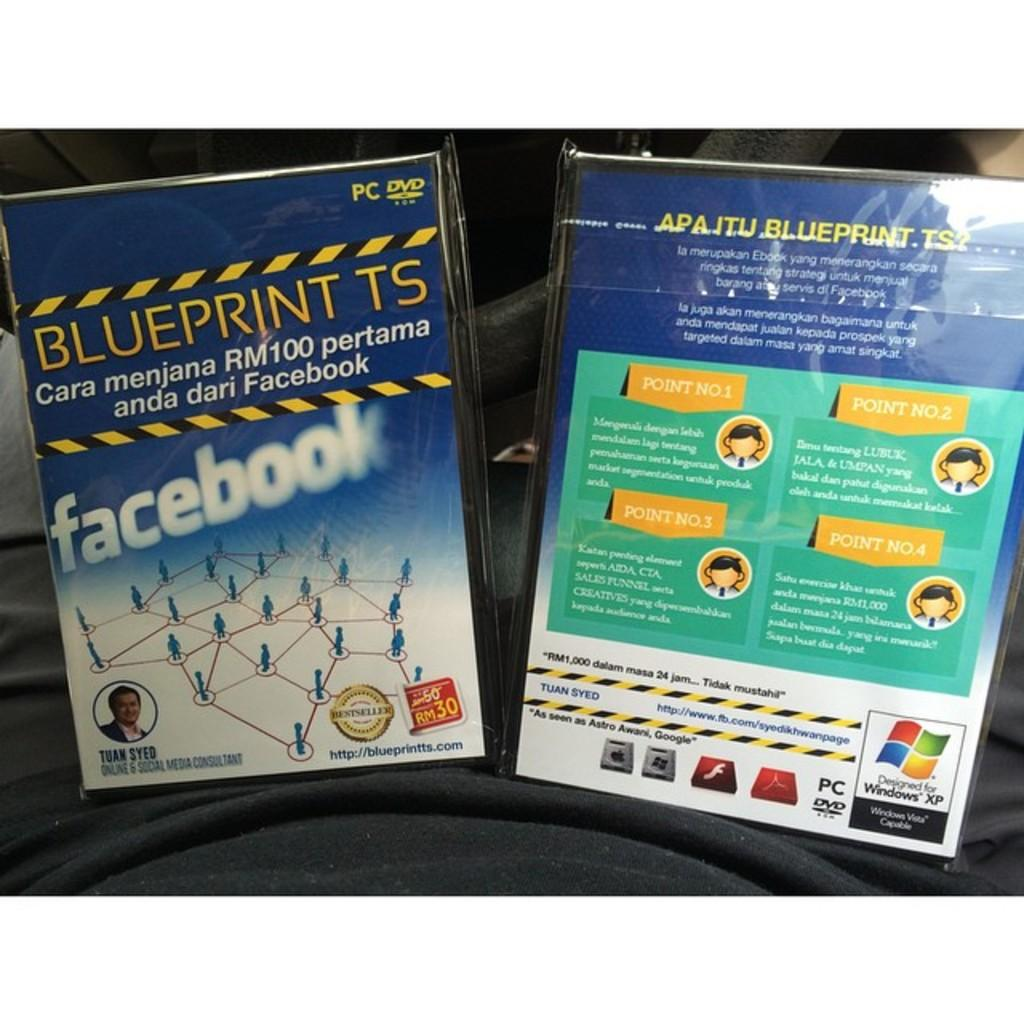What type of product packaging is visible in the image? There are DVD player boxes in the image. What can be seen on the DVD player boxes? The DVD player boxes have images and text on them. What is the color of the surface where the DVD player boxes are placed? The surface on which the DVD player boxes are placed is black. Reasoning: Let' Let's think step by step in order to produce the conversation. We start by identifying the main subject in the image, which is the DVD player boxes. Then, we expand the conversation to include details about the images and text on the boxes, as well as the color of the surface they are placed on. Each question is designed to elicit a specific detail about the image that is known from the provided facts. Absurd Question/Answer: How does the cherry contribute to the functionality of the DVD player boxes in the image? There is no cherry present in the image, so it cannot contribute to the functionality of the DVD player boxes. 